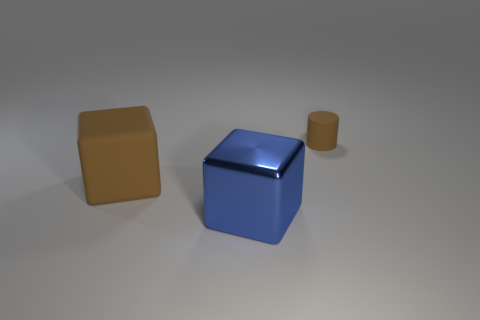Add 1 matte cylinders. How many objects exist? 4 Subtract all cylinders. How many objects are left? 2 Subtract all large objects. Subtract all big blue metal balls. How many objects are left? 1 Add 3 small cylinders. How many small cylinders are left? 4 Add 3 small brown matte cylinders. How many small brown matte cylinders exist? 4 Subtract 0 gray cylinders. How many objects are left? 3 